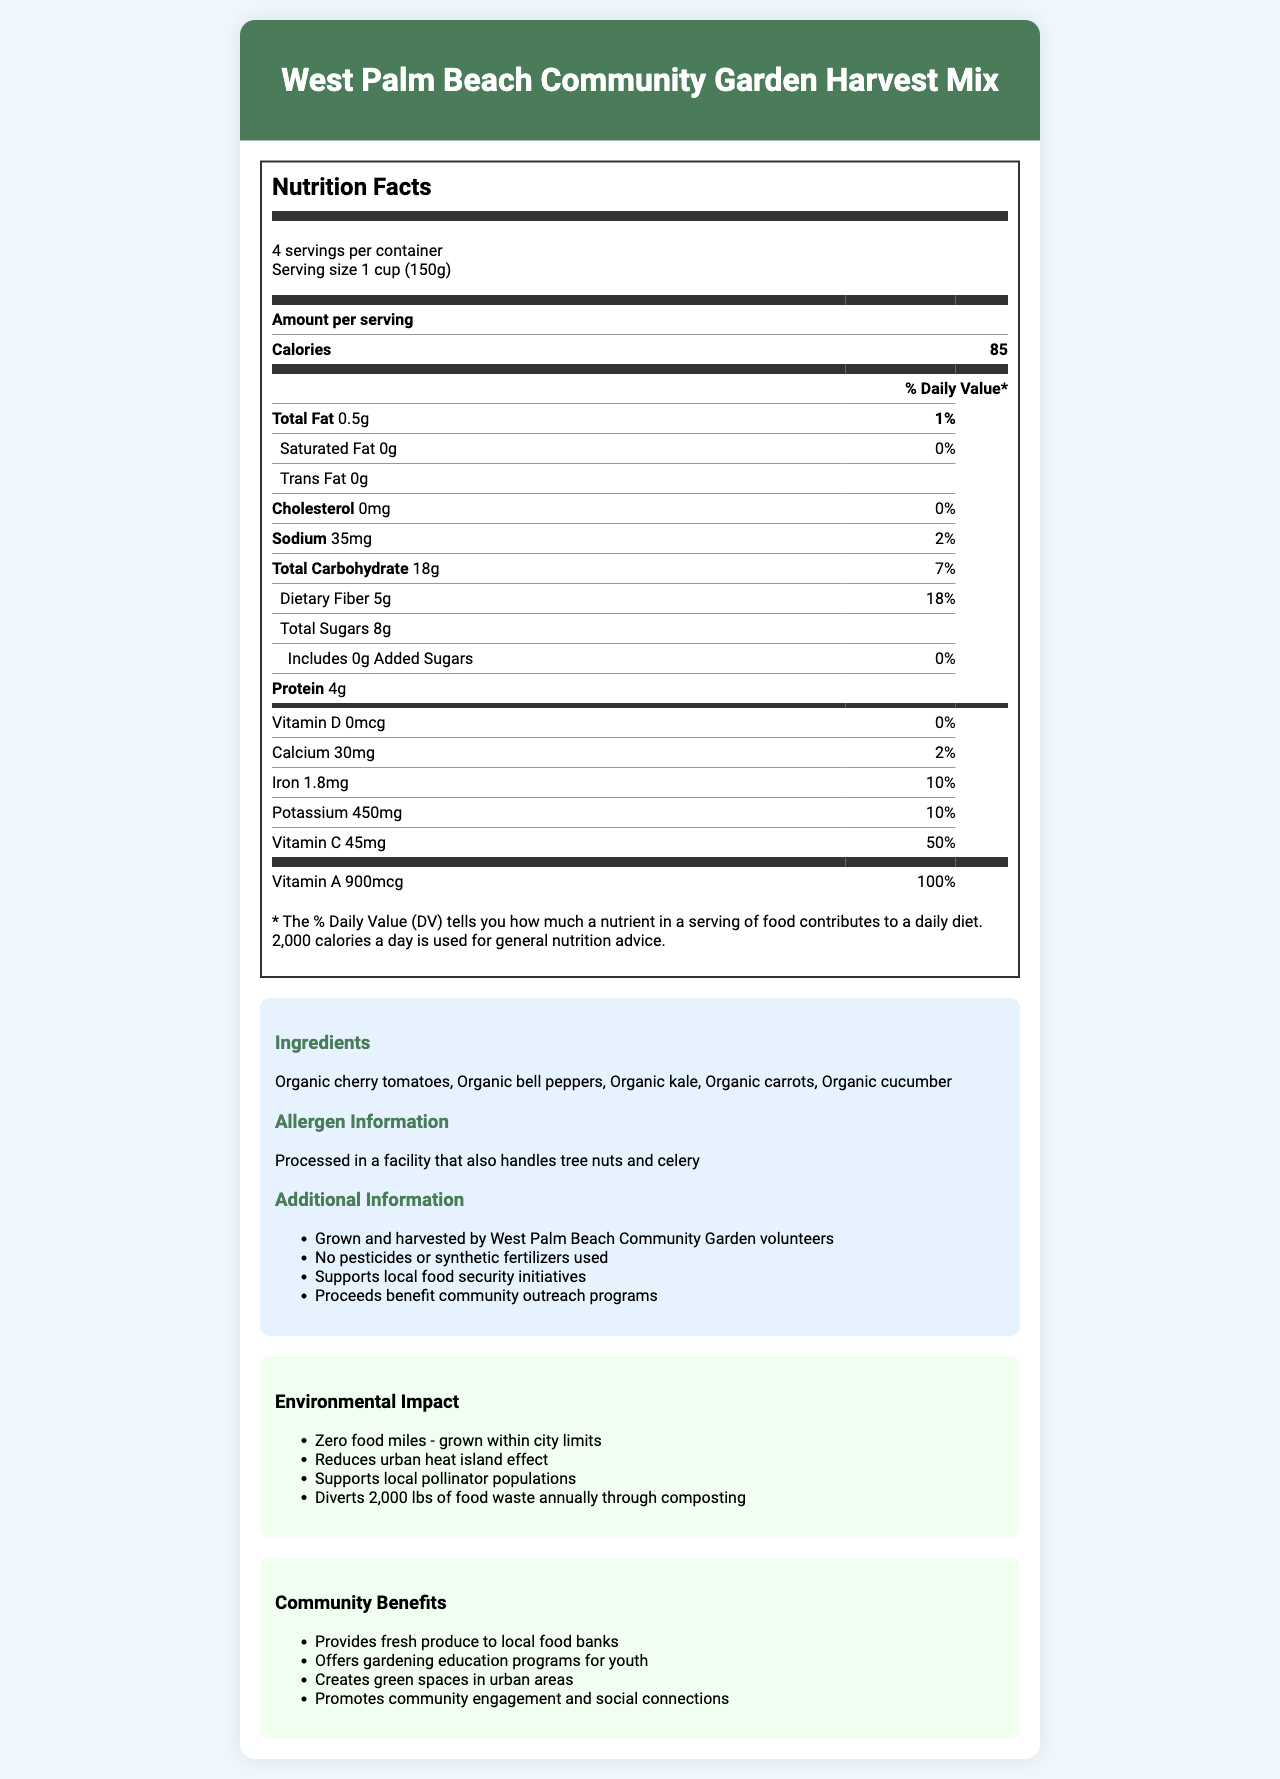who grew and harvested the West Palm Beach Community Garden Harvest Mix? The additional information section states that the produce was grown and harvested by West Palm Beach Community Garden volunteers.
Answer: West Palm Beach Community Garden volunteers what is the serving size of the West Palm Beach Community Garden Harvest Mix? The nutrition label indicates that the serving size is 1 cup (150g).
Answer: 1 cup (150g) what percentage of the daily value of dietary fiber does one serving provide? The nutrition label indicates that one serving provides 18% of the daily value of dietary fiber.
Answer: 18% how many calories are in one serving? The nutrition label shows that one serving contains 85 calories.
Answer: 85 name two vitamins that have high percentages of daily values in this mix. Vitamin C has 50% of the daily value and Vitamin A has 100% of the daily value per serving.
Answer: Vitamin C and Vitamin A which nutrient has the highest daily value percentage in one serving of this product? A. Calcium B. Iron C. Vitamin C D. Vitamin A The nutrition label shows that Vitamin A has the highest daily value percentage at 100%.
Answer: D. Vitamin A what is the total carbohydrate content in a serving of the mix? A. 5g B. 10g C. 18g D. 25g The nutrition label indicates that the total carbohydrate content is 18g per serving.
Answer: C. 18g does this product contain any added sugars? The label shows "Includes 0g Added Sugars", indicating that the product does not contain any added sugars.
Answer: No is there any cholesterol in this product? The label indicates that the amount of cholesterol is 0mg, which is 0% of the daily value.
Answer: No what is the main idea of the document? The document provides a comprehensive overview of the West Palm Beach Community Garden Harvest Mix and emphasizes its health benefits, environmental sustainability, and contributions to the community.
Answer: The document details the nutritional and community benefits of the West Palm Beach Community Garden Harvest Mix, highlighting its ingredients, nutritional content, allergen information, environmental impact, and the positive effects on the local community. what is the origin of the ingredients? The document provides information about the local cultivation of the produce but does not specify the exact origin of the individual ingredients beyond being grown in West Palm Beach.
Answer: Cannot be determined 